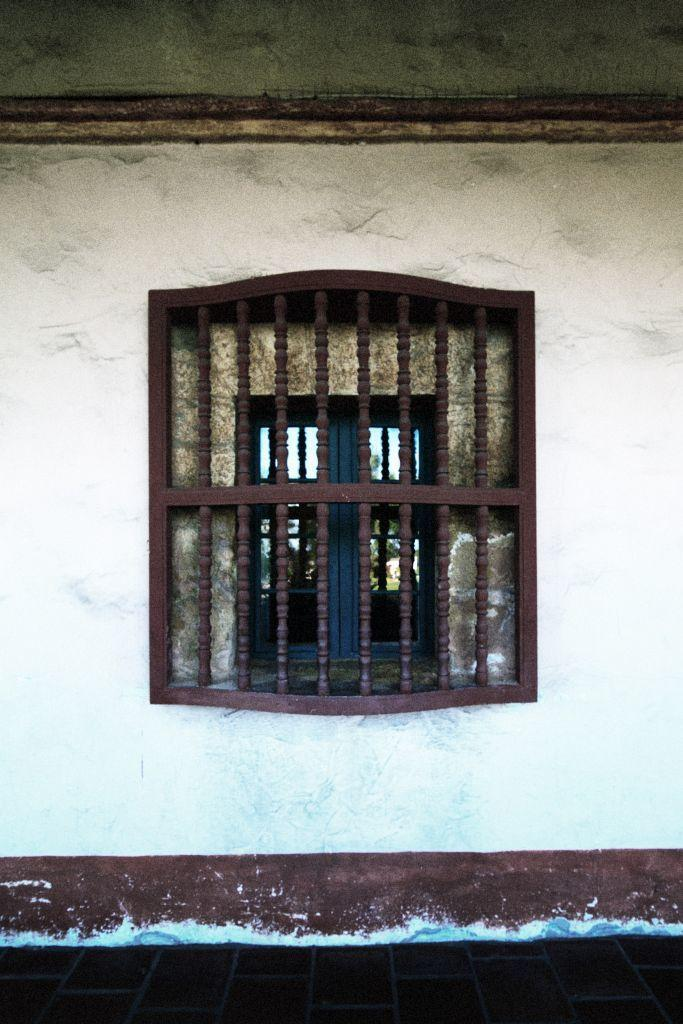What can be seen at the bottom of the image? The floor is visible at the bottom of the picture. What architectural feature is present on the wall in the image? There is a window on the wall in the image. What is visible through the window in the background? Objects are visible in the background through the window. Can you tell me how many doctors are visible in the image? There are no doctors present in the image. What scientific experiment is being conducted in the image? There is no scientific experiment depicted in the image. 